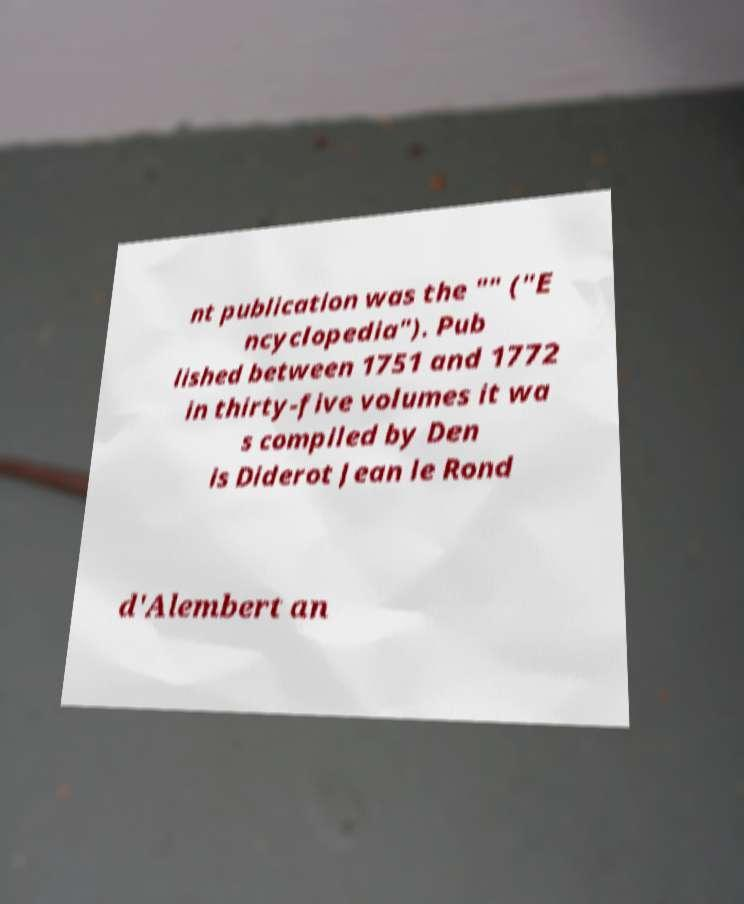What messages or text are displayed in this image? I need them in a readable, typed format. nt publication was the "" ("E ncyclopedia"). Pub lished between 1751 and 1772 in thirty-five volumes it wa s compiled by Den is Diderot Jean le Rond d'Alembert an 